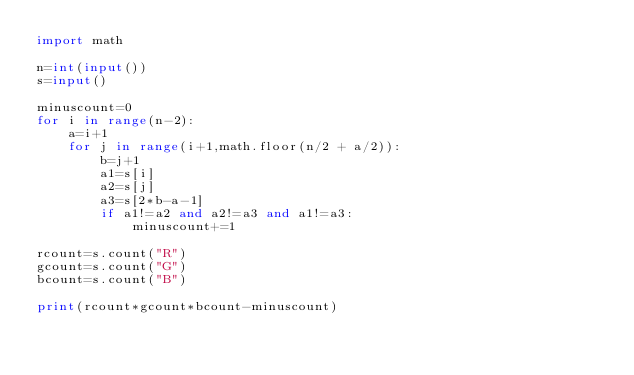Convert code to text. <code><loc_0><loc_0><loc_500><loc_500><_Python_>import math

n=int(input())
s=input()

minuscount=0
for i in range(n-2):
    a=i+1
    for j in range(i+1,math.floor(n/2 + a/2)):
        b=j+1
        a1=s[i]
        a2=s[j]
        a3=s[2*b-a-1]
        if a1!=a2 and a2!=a3 and a1!=a3:
            minuscount+=1

rcount=s.count("R")
gcount=s.count("G")
bcount=s.count("B")

print(rcount*gcount*bcount-minuscount)
        </code> 